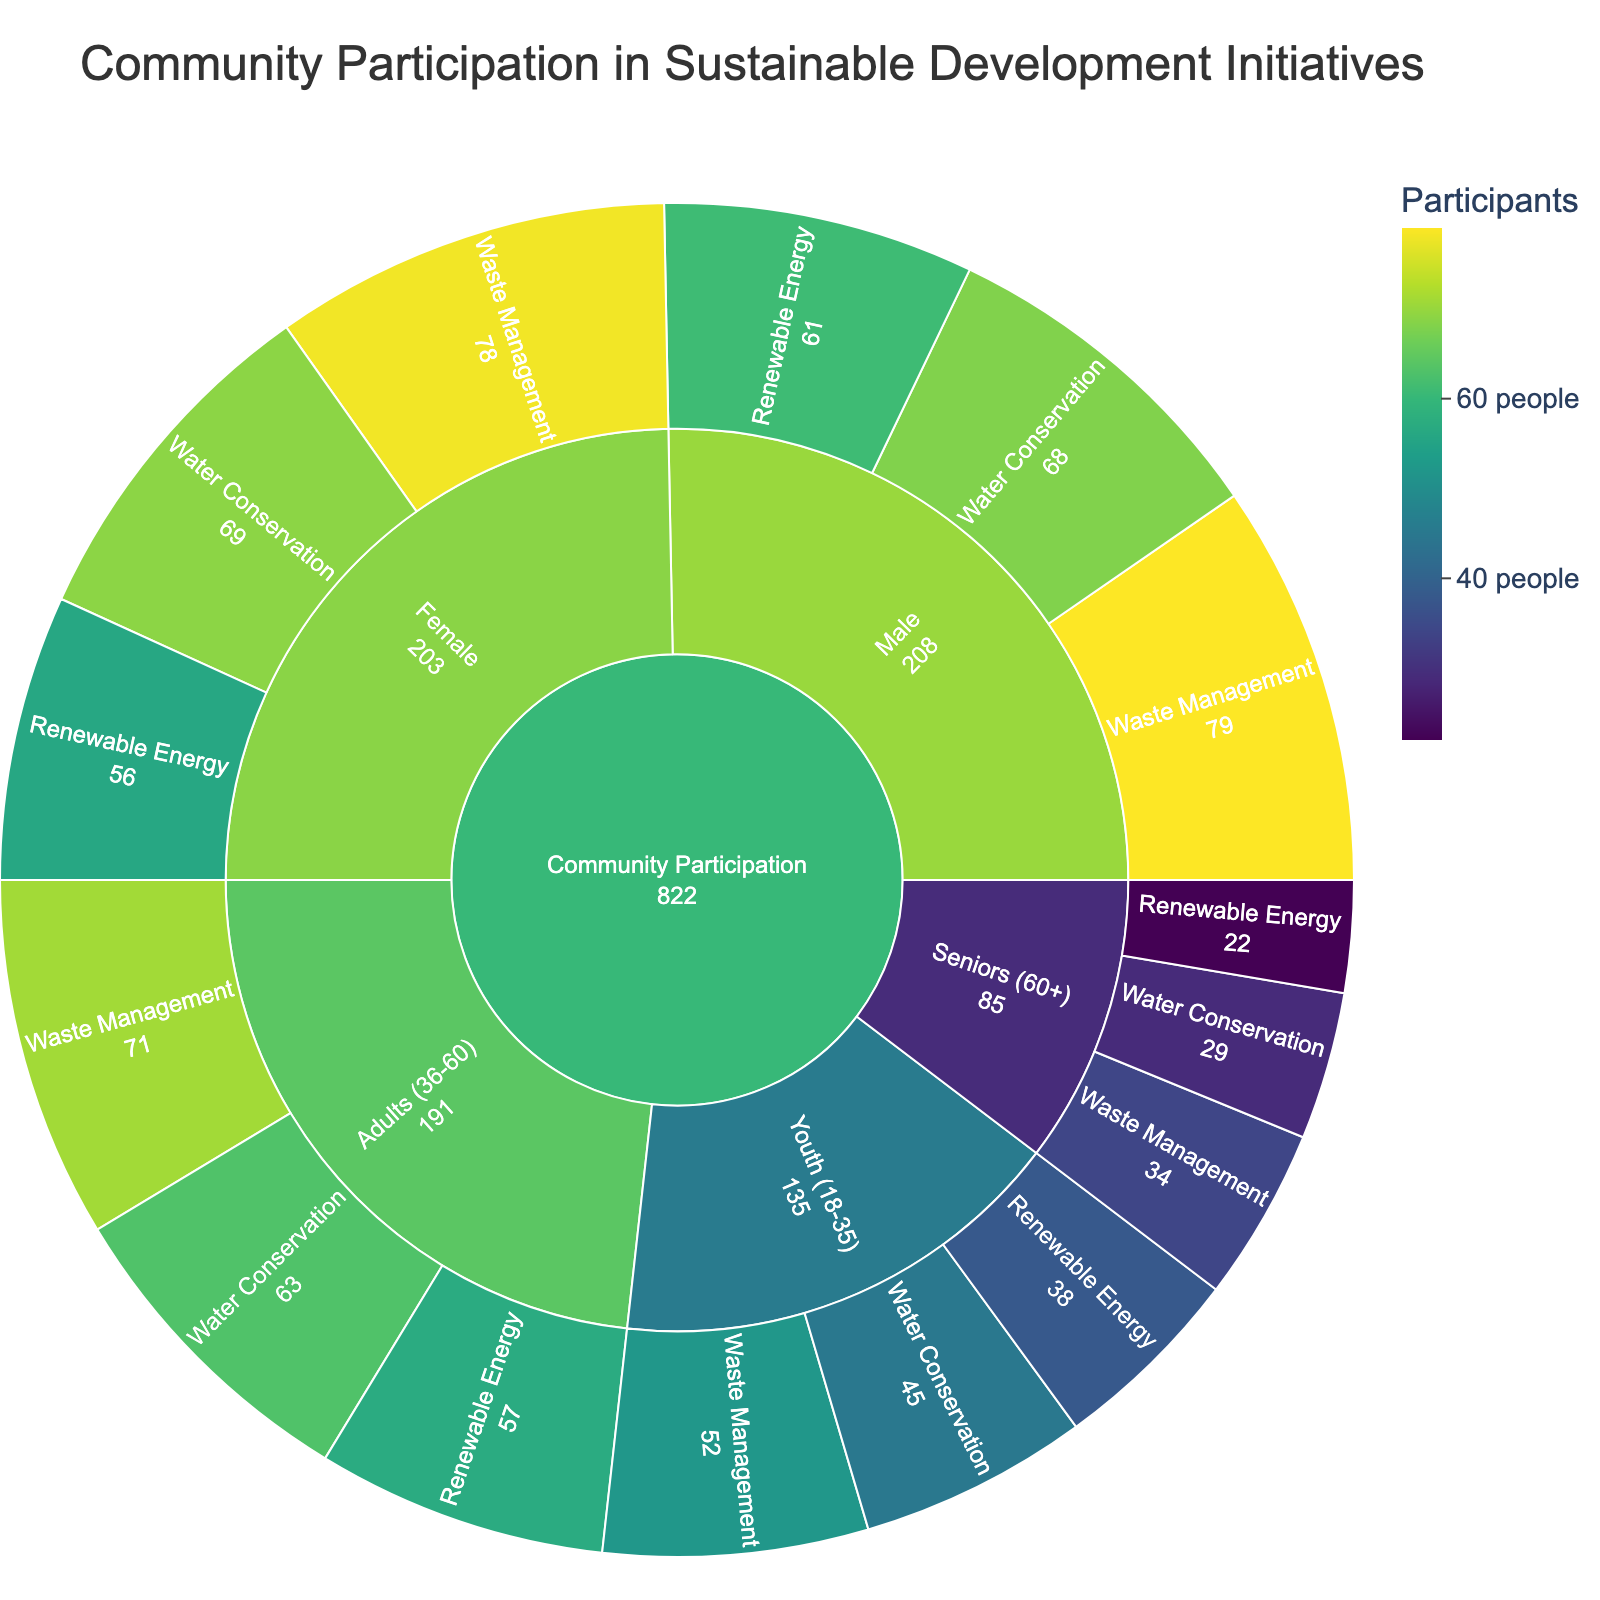What is the title of the Sunburst Plot? The title of the Sunburst Plot is located at the top of the figure and provides a summary of what it depicts.
Answer: Community Participation in Sustainable Development Initiatives Which age group in community participation has the highest number of participants in the Waste Management category? In the Sunburst Plot, locate the "Youth (18-35)" segment under "Community Participation" and then find the "Waste Management" subcategory. Compare it with the same subcategories in "Adults (36-60)" and "Seniors (60+)" to identify the highest value.
Answer: Adults (36-60) How many participants are involved in Water Conservation projects across all age groups? Sum the number of participants from the Water Conservation subcategory across Youth (18-35), Adults (36-60), and Seniors (60+). Calculate 45 + 63 + 29.
Answer: 137 Which gender has more participants in Renewable Energy initiatives? Compare the total participants in the "Renewable Energy" category under the "Male" and "Female" subcategories in the Sunburst Plot. Check their values and identify the higher number.
Answer: Male What is the combined participation of Seniors (60+) in all project types? Sum the number of participants from the Seniors (60+) subcategory across Water Conservation, Renewable Energy, and Waste Management. Calculate 29 + 22 + 34.
Answer: 85 Which project type had the least participation from Youth (18-35) age group? Within the Youth (18-35) segment, compare the participant numbers in Water Conservation, Renewable Energy, and Waste Management. The one with the lowest number is the answer.
Answer: Renewable Energy How many total participants are there in the Waste Management category regardless of age or gender? Sum the participants in the Waste Management subcategory across all age groups and genders. Calculate 52 + 71 + 34 + 79 + 78.
Answer: 314 Which age group most participated in sustainable development initiatives overall? Combine the participant numbers from all subcategories for each age group (Youth (18-35), Adults (36-60), and Seniors (60+)) and compare the totals.
Answer: Adults (36-60) What is the difference in participation between males and females in Water Conservation initiatives? Subtract the number of male participants in the Water Conservation subcategory from the female participants in the same category. Calculate 69 - 68.
Answer: 1 In the Renewable Energy project, what is the total number of participants across all demographics? Add the number of participants in the Renewable Energy subcategory for Youth (18-35), Adults (36-60), Seniors (60+), Male, and Female. Calculate 38 + 57 + 22 + 61 + 56.
Answer: 234 